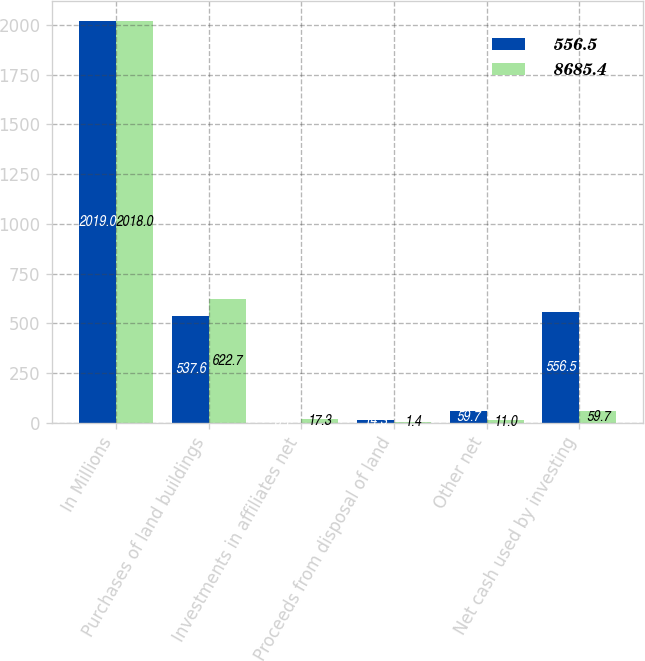Convert chart. <chart><loc_0><loc_0><loc_500><loc_500><stacked_bar_chart><ecel><fcel>In Millions<fcel>Purchases of land buildings<fcel>Investments in affiliates net<fcel>Proceeds from disposal of land<fcel>Other net<fcel>Net cash used by investing<nl><fcel>556.5<fcel>2019<fcel>537.6<fcel>0.1<fcel>14.3<fcel>59.7<fcel>556.5<nl><fcel>8685.4<fcel>2018<fcel>622.7<fcel>17.3<fcel>1.4<fcel>11<fcel>59.7<nl></chart> 